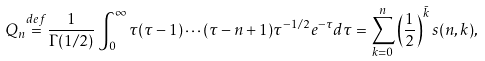Convert formula to latex. <formula><loc_0><loc_0><loc_500><loc_500>Q _ { n } { \stackrel { d e f } { = } } { \frac { 1 } { \Gamma ( 1 / 2 ) } } \int _ { 0 } ^ { \infty } \tau ( \tau - 1 ) \cdots ( \tau - n + 1 ) \tau ^ { - 1 / 2 } e ^ { - \tau } d \tau = \sum _ { k = 0 } ^ { n } \left ( { \frac { 1 } { 2 } } \right ) ^ { \bar { k } } s ( n , k ) ,</formula> 